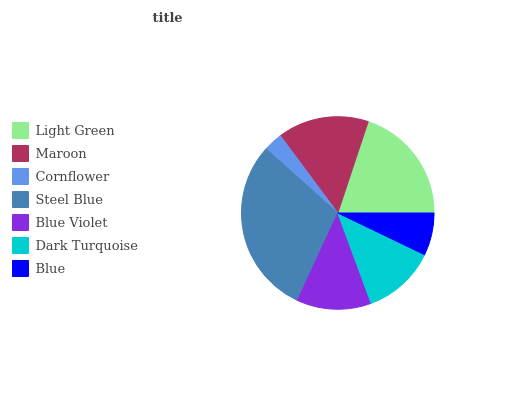Is Cornflower the minimum?
Answer yes or no. Yes. Is Steel Blue the maximum?
Answer yes or no. Yes. Is Maroon the minimum?
Answer yes or no. No. Is Maroon the maximum?
Answer yes or no. No. Is Light Green greater than Maroon?
Answer yes or no. Yes. Is Maroon less than Light Green?
Answer yes or no. Yes. Is Maroon greater than Light Green?
Answer yes or no. No. Is Light Green less than Maroon?
Answer yes or no. No. Is Blue Violet the high median?
Answer yes or no. Yes. Is Blue Violet the low median?
Answer yes or no. Yes. Is Light Green the high median?
Answer yes or no. No. Is Steel Blue the low median?
Answer yes or no. No. 